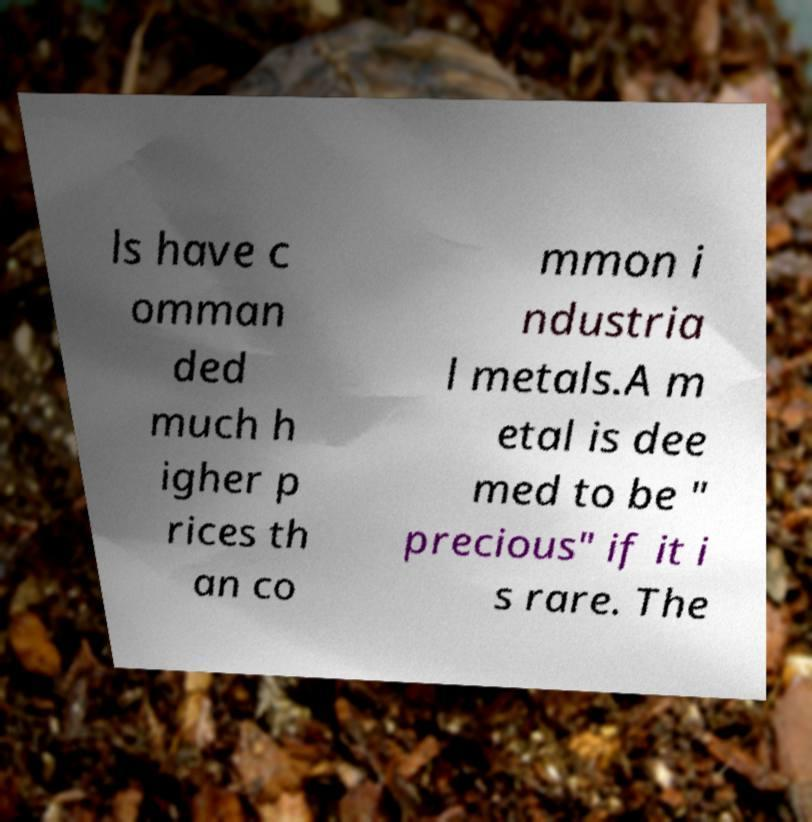For documentation purposes, I need the text within this image transcribed. Could you provide that? ls have c omman ded much h igher p rices th an co mmon i ndustria l metals.A m etal is dee med to be " precious" if it i s rare. The 